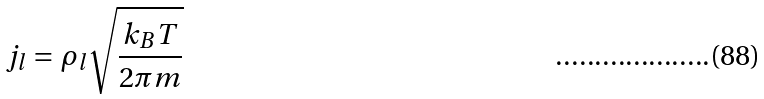<formula> <loc_0><loc_0><loc_500><loc_500>j _ { l } = \rho _ { l } \sqrt { \frac { k _ { B } T } { 2 \pi m } }</formula> 